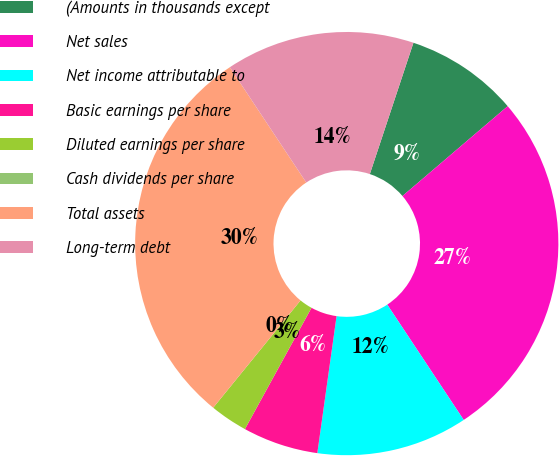Convert chart. <chart><loc_0><loc_0><loc_500><loc_500><pie_chart><fcel>(Amounts in thousands except<fcel>Net sales<fcel>Net income attributable to<fcel>Basic earnings per share<fcel>Diluted earnings per share<fcel>Cash dividends per share<fcel>Total assets<fcel>Long-term debt<nl><fcel>8.65%<fcel>26.93%<fcel>11.54%<fcel>5.77%<fcel>2.88%<fcel>0.0%<fcel>29.81%<fcel>14.42%<nl></chart> 